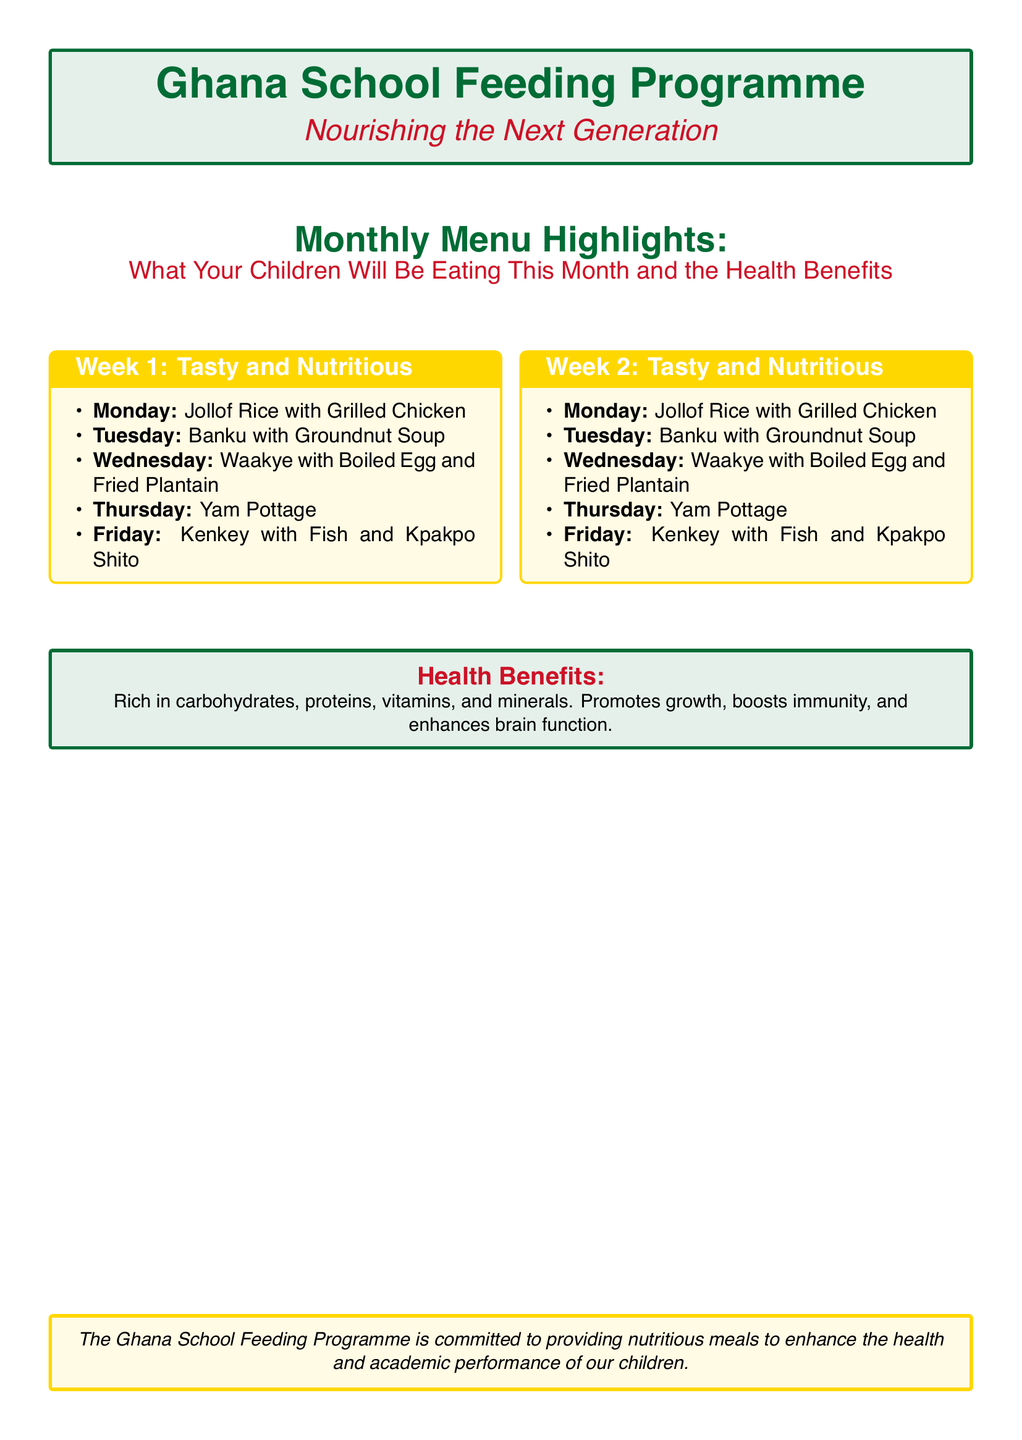What is the title of the document? The title of the document is presented prominently at the top.
Answer: Monthly Menu Highlights: What Your Children Will Be Eating This Month and the Health Benefits How many weeks of menu highlights are provided? The document mentions two weeks of menu highlights in the menu section.
Answer: 2 What is served on Wednesday of Week 2? The specific meal for Wednesday of Week 2 is clearly listed in the menu.
Answer: Waakye with Boiled Egg and Fried Plantain What type of meal is served on Friday? The document specifies the meal for Friday in both weeks; each provides a memorable dish.
Answer: Kenkey with Fish and Kpakpo Shito What is one health benefit mentioned in the flyer? The flyer outlines specific health benefits that come from the meals served.
Answer: Boosts immunity Which color is used for the background of the health benefits section? The background color for that section is noted in the document.
Answer: Light green What is the purpose of the Ghana School Feeding Programme? The concluding statement summarizes the overall mission of the programme.
Answer: Providing nutritious meals to enhance the health and academic performance of our children 